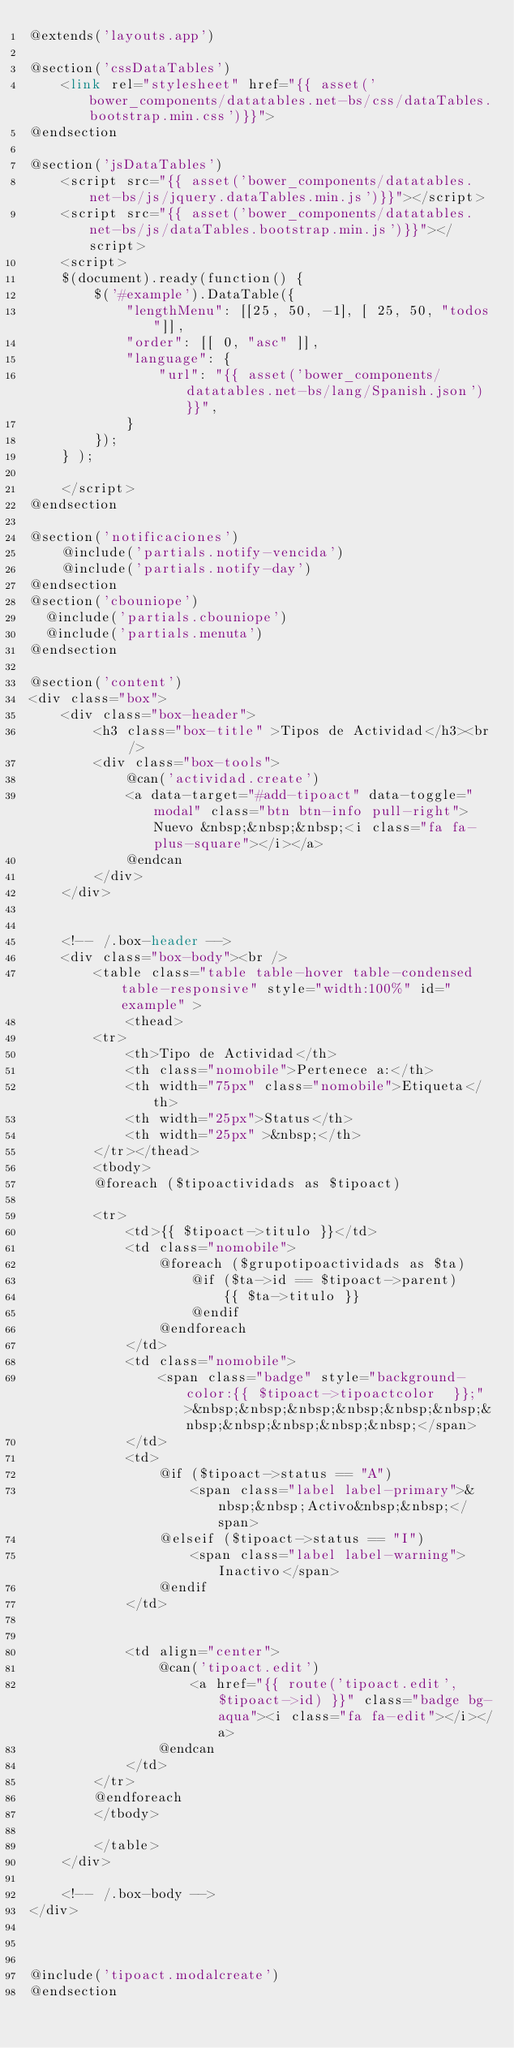<code> <loc_0><loc_0><loc_500><loc_500><_PHP_>@extends('layouts.app')

@section('cssDataTables')
    <link rel="stylesheet" href="{{ asset('bower_components/datatables.net-bs/css/dataTables.bootstrap.min.css')}}">
@endsection

@section('jsDataTables')
    <script src="{{ asset('bower_components/datatables.net-bs/js/jquery.dataTables.min.js')}}"></script>
    <script src="{{ asset('bower_components/datatables.net-bs/js/dataTables.bootstrap.min.js')}}"></script>
    <script>
    $(document).ready(function() {
        $('#example').DataTable({
            "lengthMenu": [[25, 50, -1], [ 25, 50, "todos"]],
            "order": [[ 0, "asc" ]],
            "language": {
                "url": "{{ asset('bower_components/datatables.net-bs/lang/Spanish.json') }}",
            }
        });
    } );

    </script>
@endsection

@section('notificaciones')
    @include('partials.notify-vencida')
    @include('partials.notify-day')
@endsection
@section('cbouniope')
  @include('partials.cbouniope')
  @include('partials.menuta')
@endsection

@section('content')
<div class="box">
    <div class="box-header">
        <h3 class="box-title" >Tipos de Actividad</h3><br />
        <div class="box-tools">
            @can('actividad.create')
            <a data-target="#add-tipoact" data-toggle="modal" class="btn btn-info pull-right">Nuevo &nbsp;&nbsp;&nbsp;<i class="fa fa-plus-square"></i></a>
            @endcan
        </div>
    </div>


    <!-- /.box-header -->
    <div class="box-body"><br />
        <table class="table table-hover table-condensed table-responsive" style="width:100%" id="example" >
            <thead>
        <tr>
            <th>Tipo de Actividad</th>
            <th class="nomobile">Pertenece a:</th>
            <th width="75px" class="nomobile">Etiqueta</th>
            <th width="25px">Status</th>
            <th width="25px" >&nbsp;</th>
        </tr></thead>
        <tbody>
        @foreach ($tipoactividads as $tipoact)

        <tr>
            <td>{{ $tipoact->titulo }}</td>
            <td class="nomobile">
                @foreach ($grupotipoactividads as $ta)
                    @if ($ta->id == $tipoact->parent)
                        {{ $ta->titulo }}
                    @endif
                @endforeach
            </td>
            <td class="nomobile">
                <span class="badge" style="background-color:{{ $tipoact->tipoactcolor  }};">&nbsp;&nbsp;&nbsp;&nbsp;&nbsp;&nbsp;&nbsp;&nbsp;&nbsp;&nbsp;&nbsp;</span>
            </td>
            <td>
                @if ($tipoact->status == "A")
                    <span class="label label-primary">&nbsp;&nbsp;Activo&nbsp;&nbsp;</span>
                @elseif ($tipoact->status == "I")
                    <span class="label label-warning">Inactivo</span>
                @endif
            </td>


            <td align="center">
                @can('tipoact.edit')
                    <a href="{{ route('tipoact.edit',$tipoact->id) }}" class="badge bg-aqua"><i class="fa fa-edit"></i></a>
                @endcan
            </td>
        </tr>
        @endforeach
        </tbody>

        </table>
    </div>

    <!-- /.box-body -->
</div>



@include('tipoact.modalcreate')
@endsection
</code> 